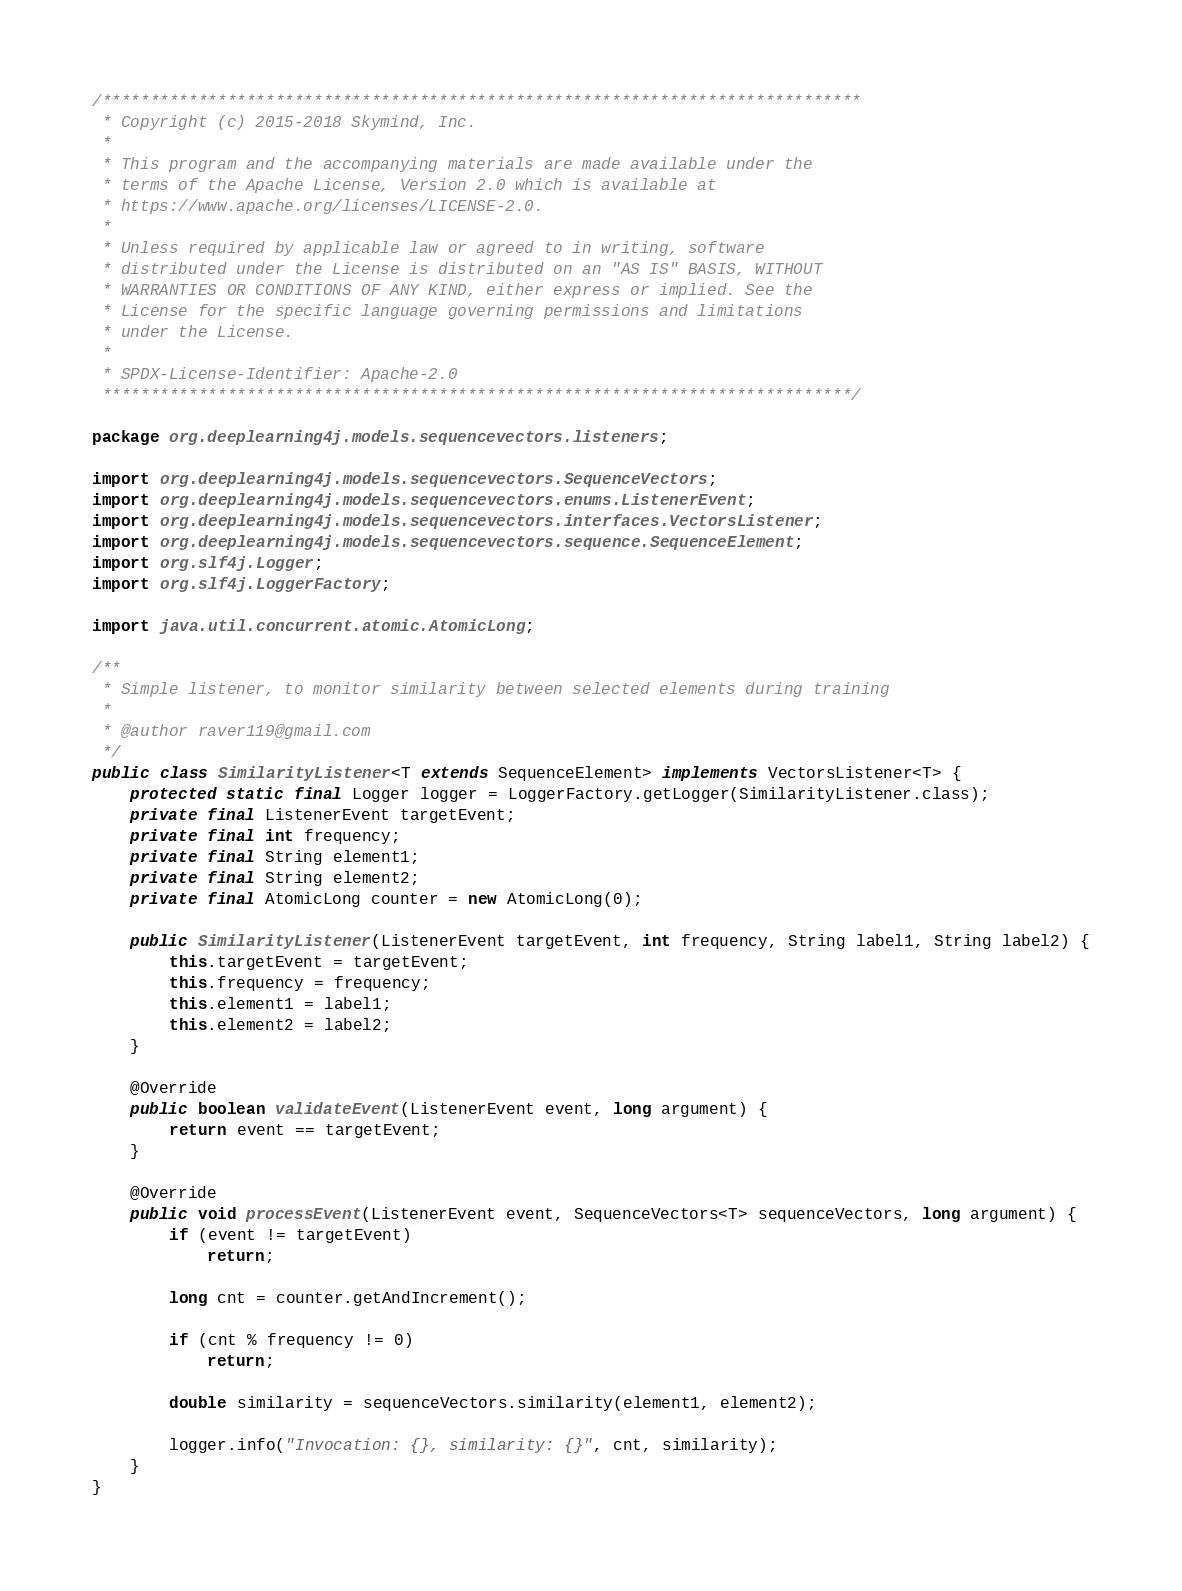Convert code to text. <code><loc_0><loc_0><loc_500><loc_500><_Java_>/*******************************************************************************
 * Copyright (c) 2015-2018 Skymind, Inc.
 *
 * This program and the accompanying materials are made available under the
 * terms of the Apache License, Version 2.0 which is available at
 * https://www.apache.org/licenses/LICENSE-2.0.
 *
 * Unless required by applicable law or agreed to in writing, software
 * distributed under the License is distributed on an "AS IS" BASIS, WITHOUT
 * WARRANTIES OR CONDITIONS OF ANY KIND, either express or implied. See the
 * License for the specific language governing permissions and limitations
 * under the License.
 *
 * SPDX-License-Identifier: Apache-2.0
 ******************************************************************************/

package org.deeplearning4j.models.sequencevectors.listeners;

import org.deeplearning4j.models.sequencevectors.SequenceVectors;
import org.deeplearning4j.models.sequencevectors.enums.ListenerEvent;
import org.deeplearning4j.models.sequencevectors.interfaces.VectorsListener;
import org.deeplearning4j.models.sequencevectors.sequence.SequenceElement;
import org.slf4j.Logger;
import org.slf4j.LoggerFactory;

import java.util.concurrent.atomic.AtomicLong;

/**
 * Simple listener, to monitor similarity between selected elements during training
 *
 * @author raver119@gmail.com
 */
public class SimilarityListener<T extends SequenceElement> implements VectorsListener<T> {
    protected static final Logger logger = LoggerFactory.getLogger(SimilarityListener.class);
    private final ListenerEvent targetEvent;
    private final int frequency;
    private final String element1;
    private final String element2;
    private final AtomicLong counter = new AtomicLong(0);

    public SimilarityListener(ListenerEvent targetEvent, int frequency, String label1, String label2) {
        this.targetEvent = targetEvent;
        this.frequency = frequency;
        this.element1 = label1;
        this.element2 = label2;
    }

    @Override
    public boolean validateEvent(ListenerEvent event, long argument) {
        return event == targetEvent;
    }

    @Override
    public void processEvent(ListenerEvent event, SequenceVectors<T> sequenceVectors, long argument) {
        if (event != targetEvent)
            return;

        long cnt = counter.getAndIncrement();

        if (cnt % frequency != 0)
            return;

        double similarity = sequenceVectors.similarity(element1, element2);

        logger.info("Invocation: {}, similarity: {}", cnt, similarity);
    }
}
</code> 